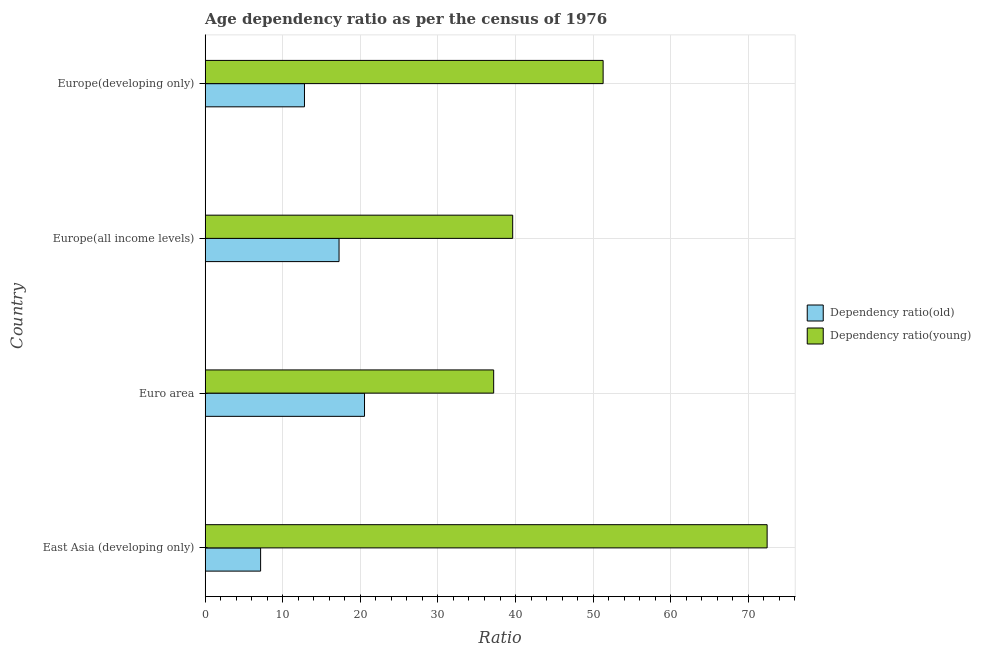How many bars are there on the 2nd tick from the bottom?
Give a very brief answer. 2. What is the label of the 4th group of bars from the top?
Keep it short and to the point. East Asia (developing only). In how many cases, is the number of bars for a given country not equal to the number of legend labels?
Offer a terse response. 0. What is the age dependency ratio(old) in Europe(developing only)?
Provide a short and direct response. 12.79. Across all countries, what is the maximum age dependency ratio(young)?
Your response must be concise. 72.43. Across all countries, what is the minimum age dependency ratio(old)?
Keep it short and to the point. 7.14. In which country was the age dependency ratio(young) maximum?
Provide a short and direct response. East Asia (developing only). In which country was the age dependency ratio(old) minimum?
Keep it short and to the point. East Asia (developing only). What is the total age dependency ratio(young) in the graph?
Your response must be concise. 200.53. What is the difference between the age dependency ratio(young) in East Asia (developing only) and that in Europe(all income levels)?
Ensure brevity in your answer.  32.8. What is the difference between the age dependency ratio(young) in Europe(developing only) and the age dependency ratio(old) in East Asia (developing only)?
Give a very brief answer. 44.15. What is the average age dependency ratio(young) per country?
Provide a succinct answer. 50.13. What is the difference between the age dependency ratio(old) and age dependency ratio(young) in Euro area?
Your response must be concise. -16.65. In how many countries, is the age dependency ratio(young) greater than 62 ?
Offer a terse response. 1. What is the ratio of the age dependency ratio(old) in Euro area to that in Europe(all income levels)?
Keep it short and to the point. 1.19. Is the difference between the age dependency ratio(young) in Europe(all income levels) and Europe(developing only) greater than the difference between the age dependency ratio(old) in Europe(all income levels) and Europe(developing only)?
Your response must be concise. No. What is the difference between the highest and the second highest age dependency ratio(young)?
Your answer should be very brief. 21.14. What is the difference between the highest and the lowest age dependency ratio(old)?
Offer a terse response. 13.39. In how many countries, is the age dependency ratio(old) greater than the average age dependency ratio(old) taken over all countries?
Your response must be concise. 2. What does the 2nd bar from the top in Europe(all income levels) represents?
Offer a very short reply. Dependency ratio(old). What does the 1st bar from the bottom in Euro area represents?
Make the answer very short. Dependency ratio(old). Are all the bars in the graph horizontal?
Provide a short and direct response. Yes. How many countries are there in the graph?
Offer a very short reply. 4. Does the graph contain any zero values?
Your answer should be compact. No. Does the graph contain grids?
Your answer should be very brief. Yes. How many legend labels are there?
Provide a succinct answer. 2. How are the legend labels stacked?
Offer a terse response. Vertical. What is the title of the graph?
Give a very brief answer. Age dependency ratio as per the census of 1976. What is the label or title of the X-axis?
Provide a succinct answer. Ratio. What is the Ratio in Dependency ratio(old) in East Asia (developing only)?
Give a very brief answer. 7.14. What is the Ratio of Dependency ratio(young) in East Asia (developing only)?
Give a very brief answer. 72.43. What is the Ratio of Dependency ratio(old) in Euro area?
Keep it short and to the point. 20.53. What is the Ratio in Dependency ratio(young) in Euro area?
Provide a short and direct response. 37.18. What is the Ratio in Dependency ratio(old) in Europe(all income levels)?
Your response must be concise. 17.25. What is the Ratio in Dependency ratio(young) in Europe(all income levels)?
Ensure brevity in your answer.  39.63. What is the Ratio of Dependency ratio(old) in Europe(developing only)?
Offer a terse response. 12.79. What is the Ratio in Dependency ratio(young) in Europe(developing only)?
Provide a short and direct response. 51.29. Across all countries, what is the maximum Ratio of Dependency ratio(old)?
Your answer should be compact. 20.53. Across all countries, what is the maximum Ratio of Dependency ratio(young)?
Your response must be concise. 72.43. Across all countries, what is the minimum Ratio in Dependency ratio(old)?
Give a very brief answer. 7.14. Across all countries, what is the minimum Ratio in Dependency ratio(young)?
Offer a terse response. 37.18. What is the total Ratio in Dependency ratio(old) in the graph?
Make the answer very short. 57.72. What is the total Ratio in Dependency ratio(young) in the graph?
Provide a succinct answer. 200.53. What is the difference between the Ratio of Dependency ratio(old) in East Asia (developing only) and that in Euro area?
Keep it short and to the point. -13.39. What is the difference between the Ratio in Dependency ratio(young) in East Asia (developing only) and that in Euro area?
Your answer should be compact. 35.25. What is the difference between the Ratio in Dependency ratio(old) in East Asia (developing only) and that in Europe(all income levels)?
Ensure brevity in your answer.  -10.11. What is the difference between the Ratio in Dependency ratio(young) in East Asia (developing only) and that in Europe(all income levels)?
Ensure brevity in your answer.  32.8. What is the difference between the Ratio of Dependency ratio(old) in East Asia (developing only) and that in Europe(developing only)?
Keep it short and to the point. -5.65. What is the difference between the Ratio in Dependency ratio(young) in East Asia (developing only) and that in Europe(developing only)?
Provide a succinct answer. 21.14. What is the difference between the Ratio of Dependency ratio(old) in Euro area and that in Europe(all income levels)?
Offer a very short reply. 3.28. What is the difference between the Ratio of Dependency ratio(young) in Euro area and that in Europe(all income levels)?
Give a very brief answer. -2.45. What is the difference between the Ratio of Dependency ratio(old) in Euro area and that in Europe(developing only)?
Your answer should be compact. 7.74. What is the difference between the Ratio of Dependency ratio(young) in Euro area and that in Europe(developing only)?
Your answer should be very brief. -14.11. What is the difference between the Ratio in Dependency ratio(old) in Europe(all income levels) and that in Europe(developing only)?
Make the answer very short. 4.46. What is the difference between the Ratio in Dependency ratio(young) in Europe(all income levels) and that in Europe(developing only)?
Your answer should be compact. -11.66. What is the difference between the Ratio of Dependency ratio(old) in East Asia (developing only) and the Ratio of Dependency ratio(young) in Euro area?
Provide a short and direct response. -30.04. What is the difference between the Ratio in Dependency ratio(old) in East Asia (developing only) and the Ratio in Dependency ratio(young) in Europe(all income levels)?
Make the answer very short. -32.49. What is the difference between the Ratio in Dependency ratio(old) in East Asia (developing only) and the Ratio in Dependency ratio(young) in Europe(developing only)?
Keep it short and to the point. -44.15. What is the difference between the Ratio in Dependency ratio(old) in Euro area and the Ratio in Dependency ratio(young) in Europe(all income levels)?
Ensure brevity in your answer.  -19.1. What is the difference between the Ratio of Dependency ratio(old) in Euro area and the Ratio of Dependency ratio(young) in Europe(developing only)?
Make the answer very short. -30.76. What is the difference between the Ratio in Dependency ratio(old) in Europe(all income levels) and the Ratio in Dependency ratio(young) in Europe(developing only)?
Your answer should be compact. -34.04. What is the average Ratio of Dependency ratio(old) per country?
Provide a succinct answer. 14.43. What is the average Ratio in Dependency ratio(young) per country?
Give a very brief answer. 50.13. What is the difference between the Ratio of Dependency ratio(old) and Ratio of Dependency ratio(young) in East Asia (developing only)?
Your response must be concise. -65.29. What is the difference between the Ratio in Dependency ratio(old) and Ratio in Dependency ratio(young) in Euro area?
Your answer should be compact. -16.65. What is the difference between the Ratio of Dependency ratio(old) and Ratio of Dependency ratio(young) in Europe(all income levels)?
Provide a short and direct response. -22.38. What is the difference between the Ratio of Dependency ratio(old) and Ratio of Dependency ratio(young) in Europe(developing only)?
Provide a succinct answer. -38.49. What is the ratio of the Ratio in Dependency ratio(old) in East Asia (developing only) to that in Euro area?
Your answer should be very brief. 0.35. What is the ratio of the Ratio in Dependency ratio(young) in East Asia (developing only) to that in Euro area?
Give a very brief answer. 1.95. What is the ratio of the Ratio in Dependency ratio(old) in East Asia (developing only) to that in Europe(all income levels)?
Offer a terse response. 0.41. What is the ratio of the Ratio in Dependency ratio(young) in East Asia (developing only) to that in Europe(all income levels)?
Give a very brief answer. 1.83. What is the ratio of the Ratio in Dependency ratio(old) in East Asia (developing only) to that in Europe(developing only)?
Ensure brevity in your answer.  0.56. What is the ratio of the Ratio of Dependency ratio(young) in East Asia (developing only) to that in Europe(developing only)?
Ensure brevity in your answer.  1.41. What is the ratio of the Ratio in Dependency ratio(old) in Euro area to that in Europe(all income levels)?
Give a very brief answer. 1.19. What is the ratio of the Ratio in Dependency ratio(young) in Euro area to that in Europe(all income levels)?
Your answer should be compact. 0.94. What is the ratio of the Ratio of Dependency ratio(old) in Euro area to that in Europe(developing only)?
Provide a succinct answer. 1.6. What is the ratio of the Ratio of Dependency ratio(young) in Euro area to that in Europe(developing only)?
Your answer should be very brief. 0.72. What is the ratio of the Ratio in Dependency ratio(old) in Europe(all income levels) to that in Europe(developing only)?
Offer a very short reply. 1.35. What is the ratio of the Ratio in Dependency ratio(young) in Europe(all income levels) to that in Europe(developing only)?
Provide a succinct answer. 0.77. What is the difference between the highest and the second highest Ratio in Dependency ratio(old)?
Give a very brief answer. 3.28. What is the difference between the highest and the second highest Ratio of Dependency ratio(young)?
Ensure brevity in your answer.  21.14. What is the difference between the highest and the lowest Ratio of Dependency ratio(old)?
Give a very brief answer. 13.39. What is the difference between the highest and the lowest Ratio in Dependency ratio(young)?
Your answer should be compact. 35.25. 